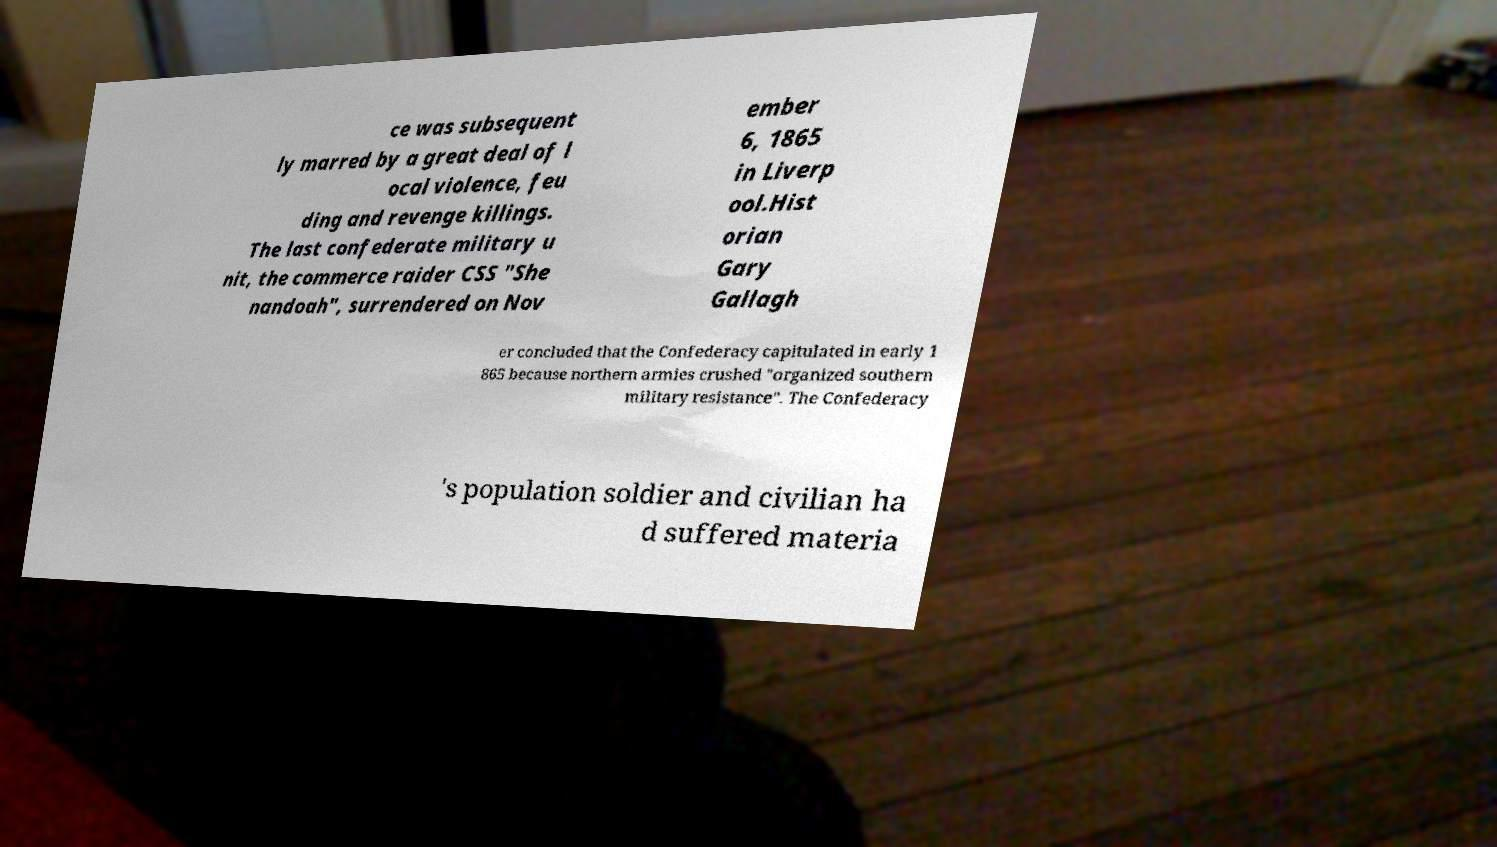Could you extract and type out the text from this image? ce was subsequent ly marred by a great deal of l ocal violence, feu ding and revenge killings. The last confederate military u nit, the commerce raider CSS "She nandoah", surrendered on Nov ember 6, 1865 in Liverp ool.Hist orian Gary Gallagh er concluded that the Confederacy capitulated in early 1 865 because northern armies crushed "organized southern military resistance". The Confederacy 's population soldier and civilian ha d suffered materia 